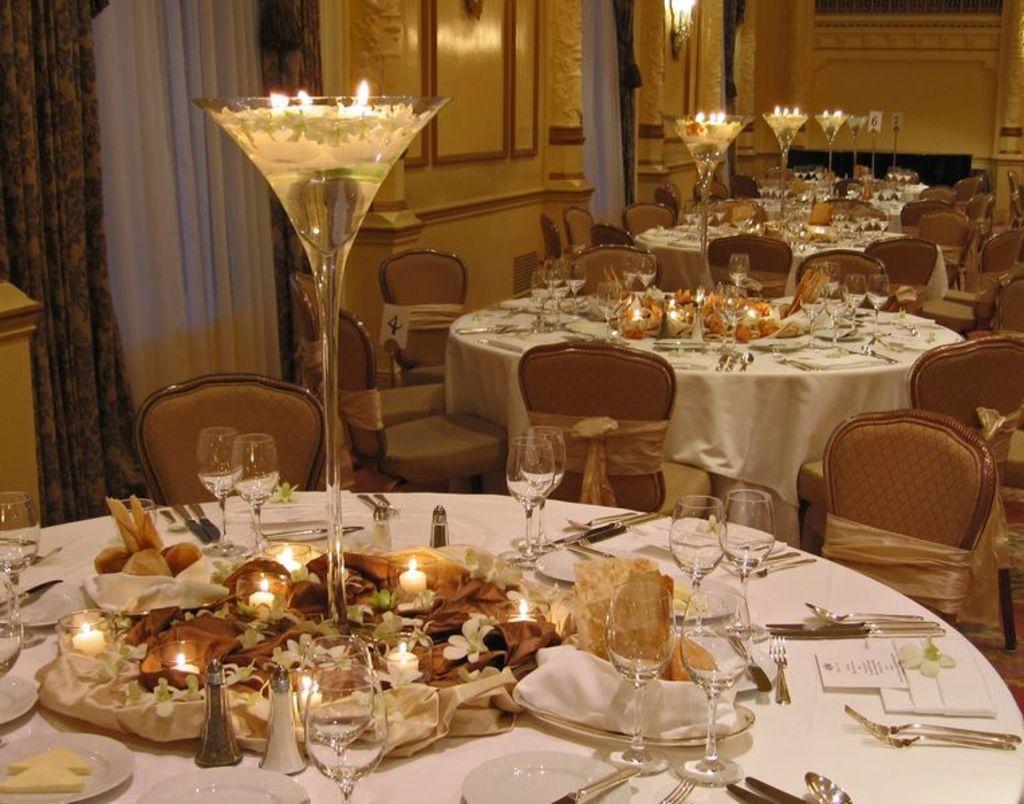Please provide a concise description of this image. As we can see in the image there are curtains, tables, chairs and on tables there are glasses and candles. 